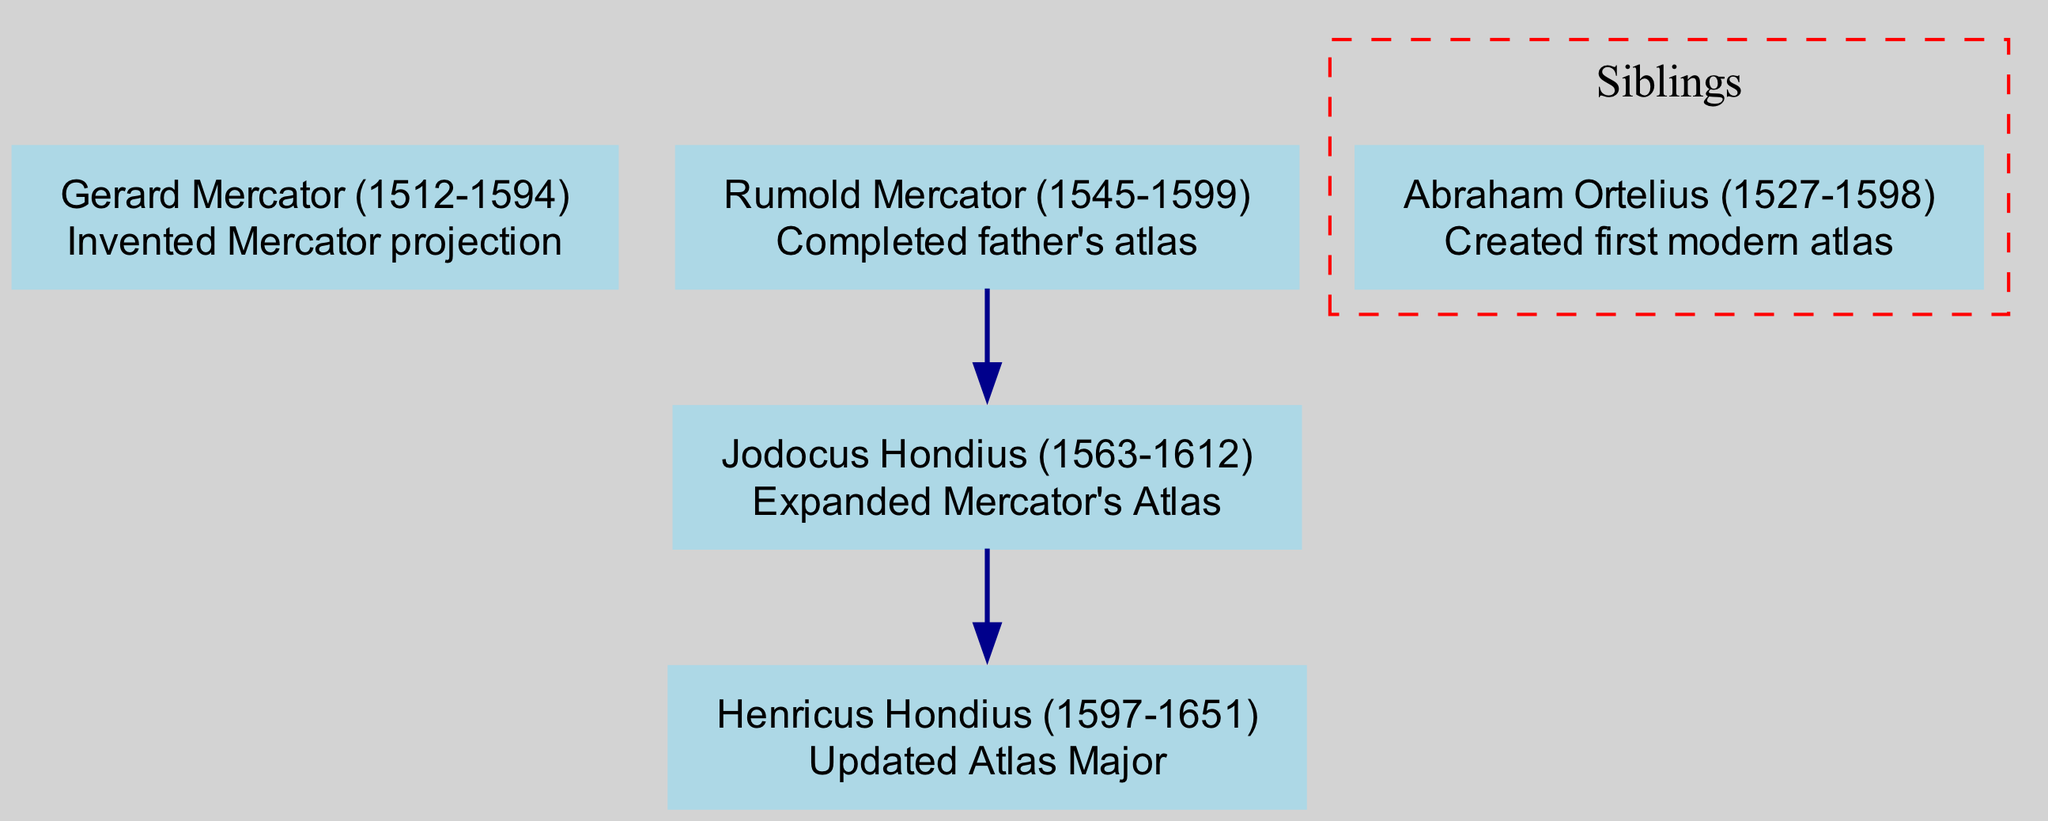What is the full name of the family represented in this diagram? The family is identified as the "Mercator Family," explicitly stated at the top of the diagram.
Answer: Mercator Family Who created the first modern atlas? Abraham Ortelius is indicated as a sibling to the Mercator family, with his contribution specifically noted as creating the first modern atlas.
Answer: Abraham Ortelius What contribution did Gerard Mercator make to cartography? Gerard Mercator's contribution is listed as the invention of the "Mercator projection," which is noted next to his name in the diagram.
Answer: Invented Mercator projection How many children did Rumold Mercator have? Rumold Mercator is shown to have one descendant, Jodocus Hondius, indicated by the presence of a single child in the diagram.
Answer: 1 What is the relationship between Jodocus Hondius and Henricus Hondius? Jodocus Hondius is shown as a child of Rumold Mercator and is further indicated to have Henricus Hondius as a child, establishing them as parent and child respectively.
Answer: Parent-Child Which explorer expanded Mercator's atlas? Jodocus Hondius is specifically highlighted for his contribution to expanding Mercator's Atlas, which appears next to his name in the diagram.
Answer: Jodocus Hondius How many generations of explorers are presented in this family lineage? The diagram includes three generations: Gerard Mercator, his son Rumold Mercator, and his grandson Jodocus Hondius, plus Henricus Hondius, making it three generations in total.
Answer: 3 What is the contribution of Henricus Hondius? Henricus Hondius's contribution is stated as updating the "Atlas Major," indicated next to his name in the diagram.
Answer: Updated Atlas Major What color is used for the nodes in this family tree diagram? The nodes are styled with a light blue color, as defined in the diagram's formatting.
Answer: Light blue 